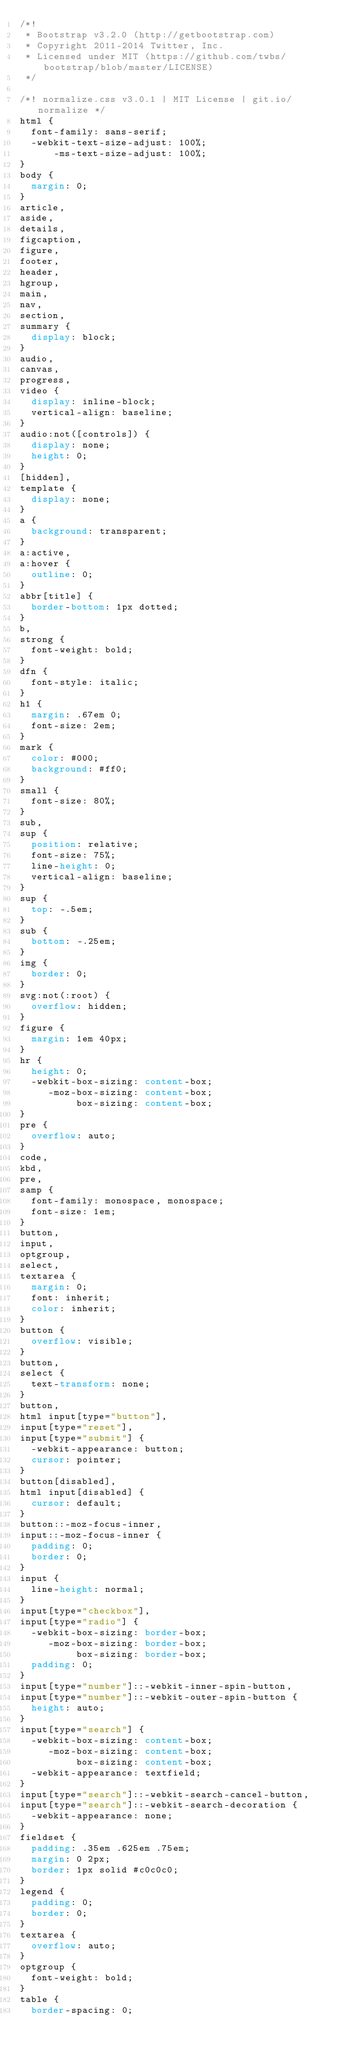<code> <loc_0><loc_0><loc_500><loc_500><_CSS_>/*!
 * Bootstrap v3.2.0 (http://getbootstrap.com)
 * Copyright 2011-2014 Twitter, Inc.
 * Licensed under MIT (https://github.com/twbs/bootstrap/blob/master/LICENSE)
 */

/*! normalize.css v3.0.1 | MIT License | git.io/normalize */
html {
  font-family: sans-serif;
  -webkit-text-size-adjust: 100%;
      -ms-text-size-adjust: 100%;
}
body {
  margin: 0;
}
article,
aside,
details,
figcaption,
figure,
footer,
header,
hgroup,
main,
nav,
section,
summary {
  display: block;
}
audio,
canvas,
progress,
video {
  display: inline-block;
  vertical-align: baseline;
}
audio:not([controls]) {
  display: none;
  height: 0;
}
[hidden],
template {
  display: none;
}
a {
  background: transparent;
}
a:active,
a:hover {
  outline: 0;
}
abbr[title] {
  border-bottom: 1px dotted;
}
b,
strong {
  font-weight: bold;
}
dfn {
  font-style: italic;
}
h1 {
  margin: .67em 0;
  font-size: 2em;
}
mark {
  color: #000;
  background: #ff0;
}
small {
  font-size: 80%;
}
sub,
sup {
  position: relative;
  font-size: 75%;
  line-height: 0;
  vertical-align: baseline;
}
sup {
  top: -.5em;
}
sub {
  bottom: -.25em;
}
img {
  border: 0;
}
svg:not(:root) {
  overflow: hidden;
}
figure {
  margin: 1em 40px;
}
hr {
  height: 0;
  -webkit-box-sizing: content-box;
     -moz-box-sizing: content-box;
          box-sizing: content-box;
}
pre {
  overflow: auto;
}
code,
kbd,
pre,
samp {
  font-family: monospace, monospace;
  font-size: 1em;
}
button,
input,
optgroup,
select,
textarea {
  margin: 0;
  font: inherit;
  color: inherit;
}
button {
  overflow: visible;
}
button,
select {
  text-transform: none;
}
button,
html input[type="button"],
input[type="reset"],
input[type="submit"] {
  -webkit-appearance: button;
  cursor: pointer;
}
button[disabled],
html input[disabled] {
  cursor: default;
}
button::-moz-focus-inner,
input::-moz-focus-inner {
  padding: 0;
  border: 0;
}
input {
  line-height: normal;
}
input[type="checkbox"],
input[type="radio"] {
  -webkit-box-sizing: border-box;
     -moz-box-sizing: border-box;
          box-sizing: border-box;
  padding: 0;
}
input[type="number"]::-webkit-inner-spin-button,
input[type="number"]::-webkit-outer-spin-button {
  height: auto;
}
input[type="search"] {
  -webkit-box-sizing: content-box;
     -moz-box-sizing: content-box;
          box-sizing: content-box;
  -webkit-appearance: textfield;
}
input[type="search"]::-webkit-search-cancel-button,
input[type="search"]::-webkit-search-decoration {
  -webkit-appearance: none;
}
fieldset {
  padding: .35em .625em .75em;
  margin: 0 2px;
  border: 1px solid #c0c0c0;
}
legend {
  padding: 0;
  border: 0;
}
textarea {
  overflow: auto;
}
optgroup {
  font-weight: bold;
}
table {
  border-spacing: 0;</code> 